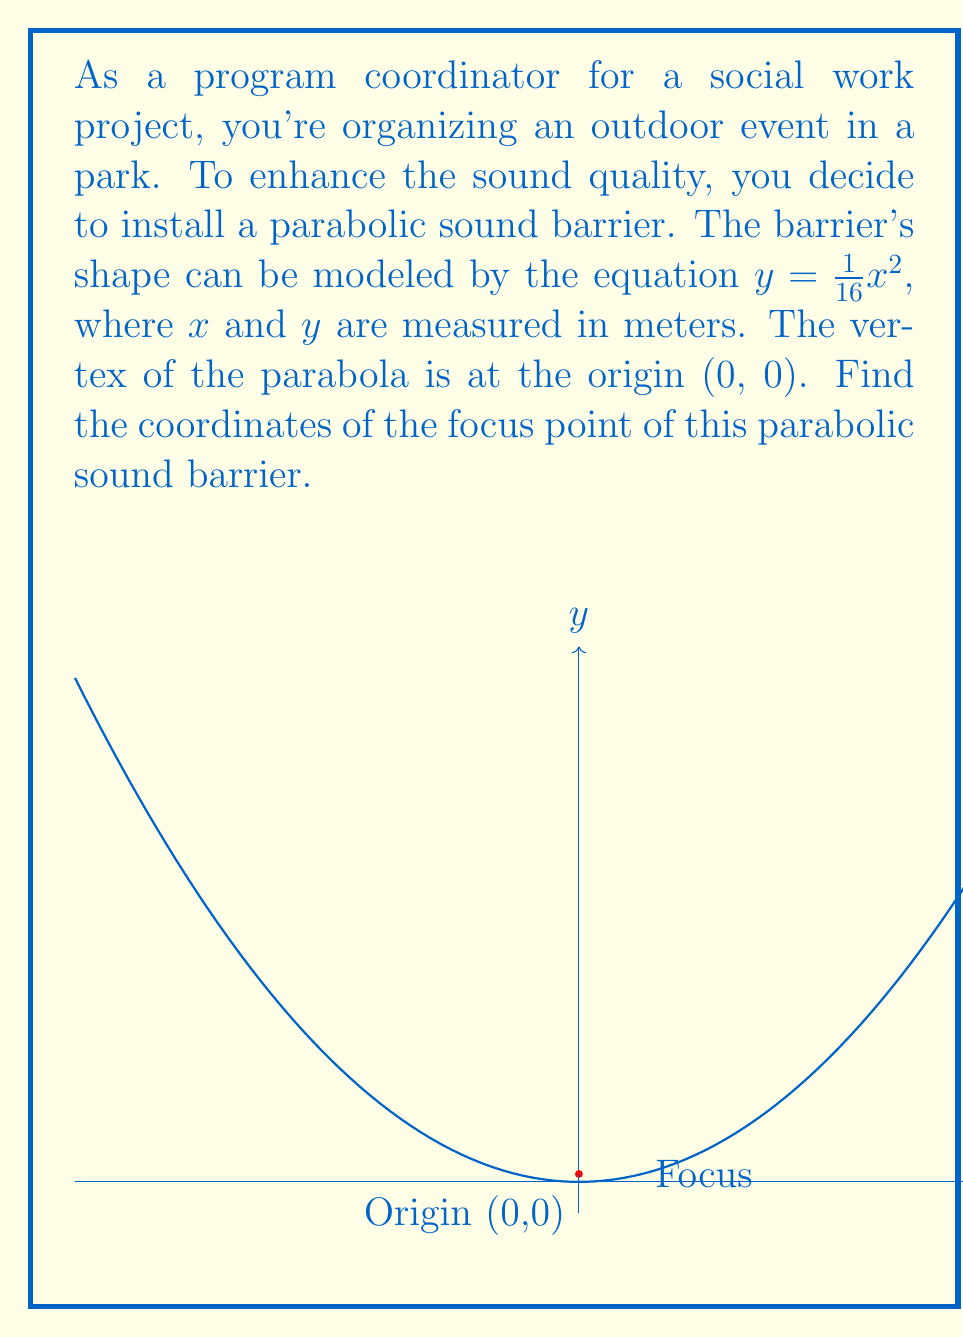Give your solution to this math problem. Let's approach this step-by-step:

1) The general form of a parabola with vertex at the origin is:
   $y = ax^2$, where $a$ is a non-zero constant.

2) In our case, $a = \frac{1}{16}$.

3) For a parabola in this form, the focus is located on the y-axis at a distance of $\frac{1}{4a}$ from the vertex.

4) To find the y-coordinate of the focus, we calculate:
   $y = \frac{1}{4a} = \frac{1}{4(\frac{1}{16})} = \frac{1}{4} \cdot 16 = 4$

5) Since the parabola opens upward (a > 0), the focus is above the vertex.

6) The x-coordinate of the focus is 0, as it lies on the y-axis.

Therefore, the coordinates of the focus are (0, 0.25) meters.
Answer: (0, 0.25) meters 